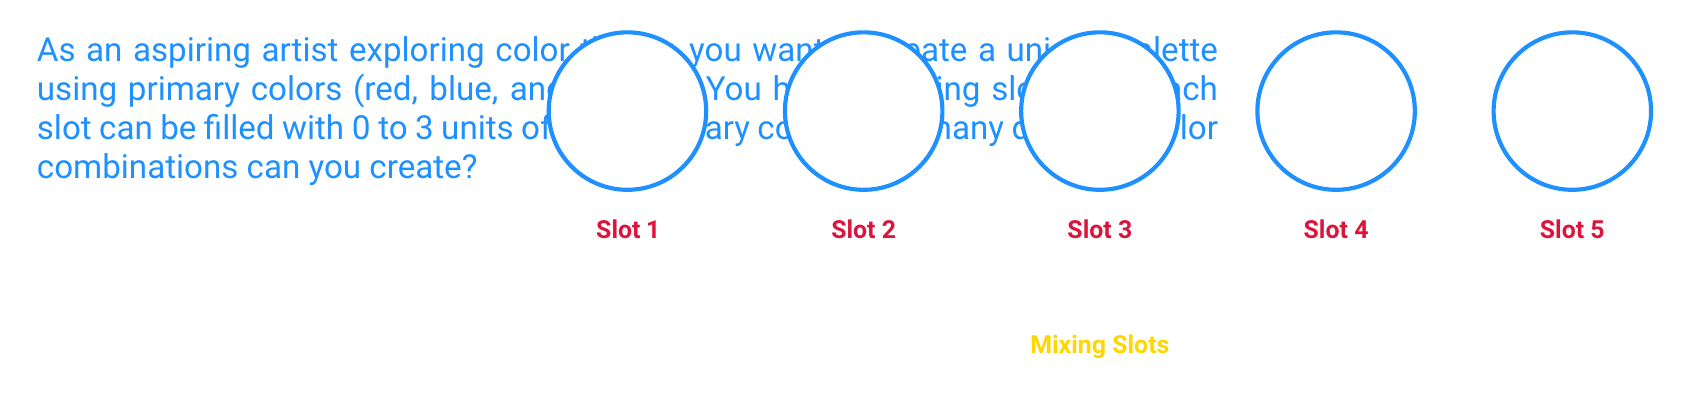Solve this math problem. Let's approach this step-by-step:

1) For each slot, we need to consider how many ways we can fill it with the primary colors.

2) For each primary color in a slot, we have 4 options: 0, 1, 2, or 3 units.

3) Since we have 3 primary colors (red, blue, yellow) and each can be chosen independently, for each slot we have:

   $4 \times 4 \times 4 = 4^3 = 64$ possibilities

4) We have 5 slots in total, and each slot can be filled independently of the others.

5) Therefore, we can use the multiplication principle. The total number of combinations is:

   $64^5 = (4^3)^5 = 4^{15}$

6) Let's calculate this:
   
   $4^{15} = 1,073,741,824$

This large number reflects the vast array of subtle color variations possible, showcasing the richness of color mixing in art.
Answer: $4^{15} = 1,073,741,824$ 